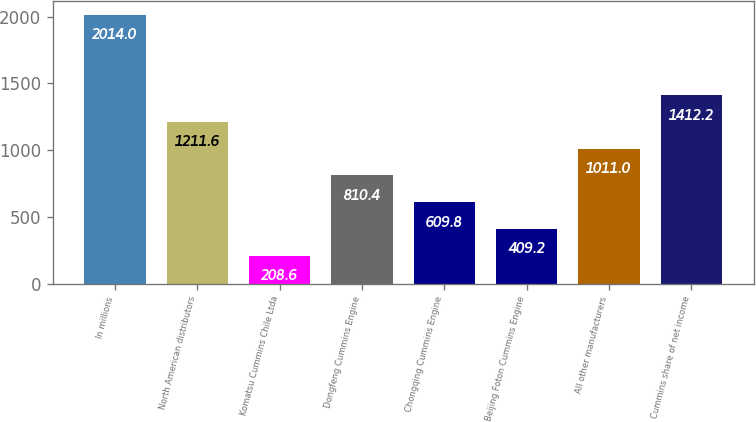<chart> <loc_0><loc_0><loc_500><loc_500><bar_chart><fcel>In millions<fcel>North American distributors<fcel>Komatsu Cummins Chile Ltda<fcel>Dongfeng Cummins Engine<fcel>Chongqing Cummins Engine<fcel>Beijing Foton Cummins Engine<fcel>All other manufacturers<fcel>Cummins share of net income<nl><fcel>2014<fcel>1211.6<fcel>208.6<fcel>810.4<fcel>609.8<fcel>409.2<fcel>1011<fcel>1412.2<nl></chart> 